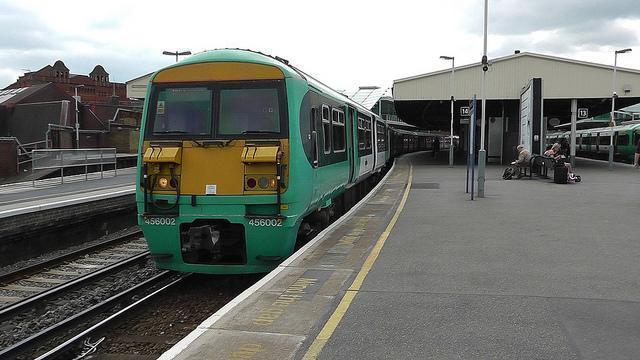What are the people on the bench doing?
From the following four choices, select the correct answer to address the question.
Options: Working, sleeping, gaming, waiting. Waiting. 